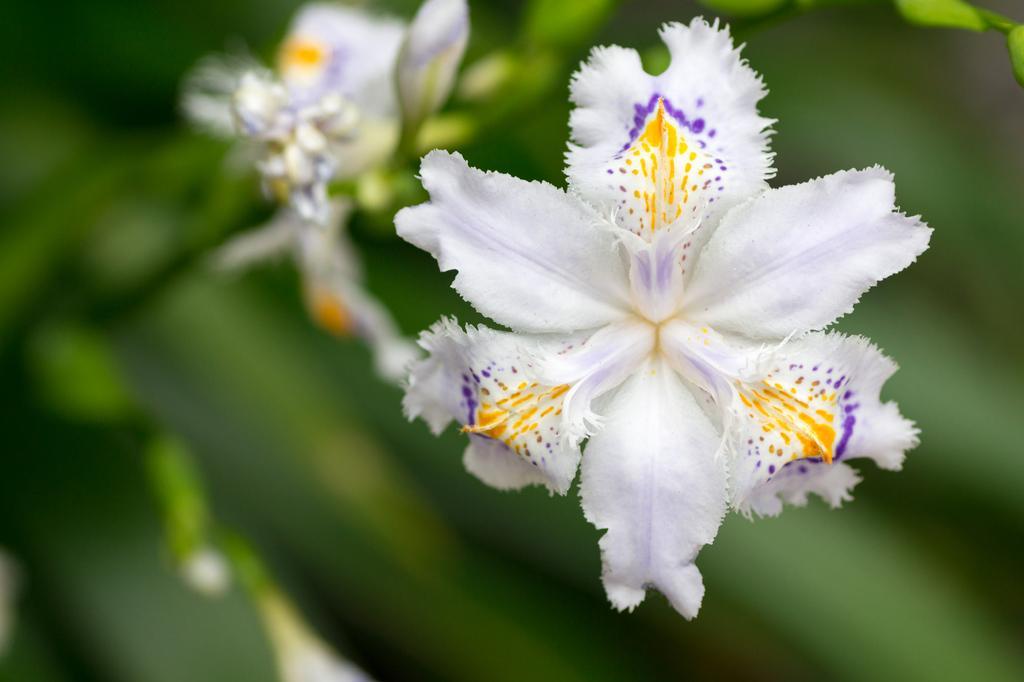How would you summarize this image in a sentence or two? This picture shows so white color flowers with yellow and blue color dots on the flowers. 